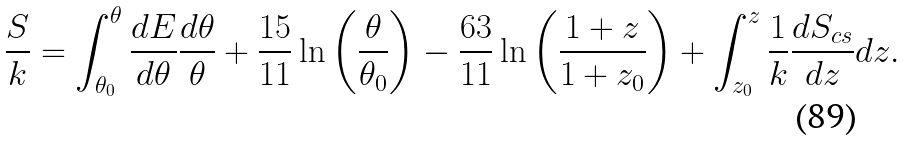Convert formula to latex. <formula><loc_0><loc_0><loc_500><loc_500>\frac { S } { k } = \int _ { \theta _ { 0 } } ^ { \theta } \frac { d E } { d \theta } \frac { d \theta } { \theta } + \frac { 1 5 } { 1 1 } \ln \left ( \frac { \theta } { \theta _ { 0 } } \right ) - \frac { 6 3 } { 1 1 } \ln \left ( \frac { 1 + z } { 1 + z _ { 0 } } \right ) + \int _ { z _ { 0 } } ^ { z } \frac { 1 } { k } \frac { d S _ { c s } } { d z } d z .</formula> 